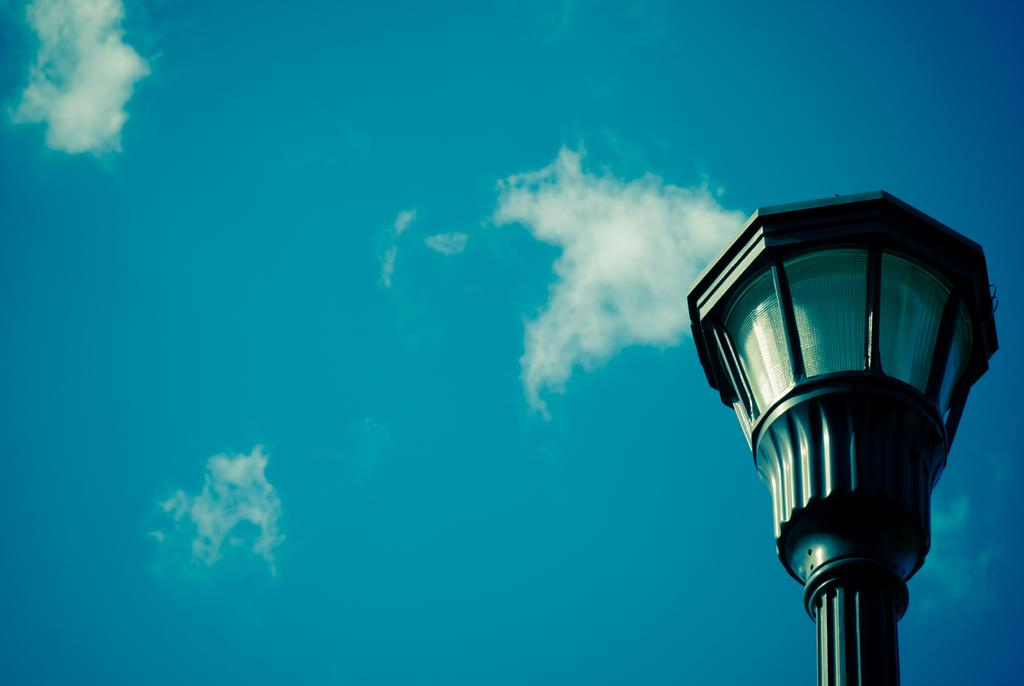What object can be seen in the image that provides light? There is a street light in the image. What part of the natural environment is visible in the image? The sky is visible in the image. What type of wool is being used to make soap in the image? There is no wool or soap present in the image; it only features a street light and the sky. 